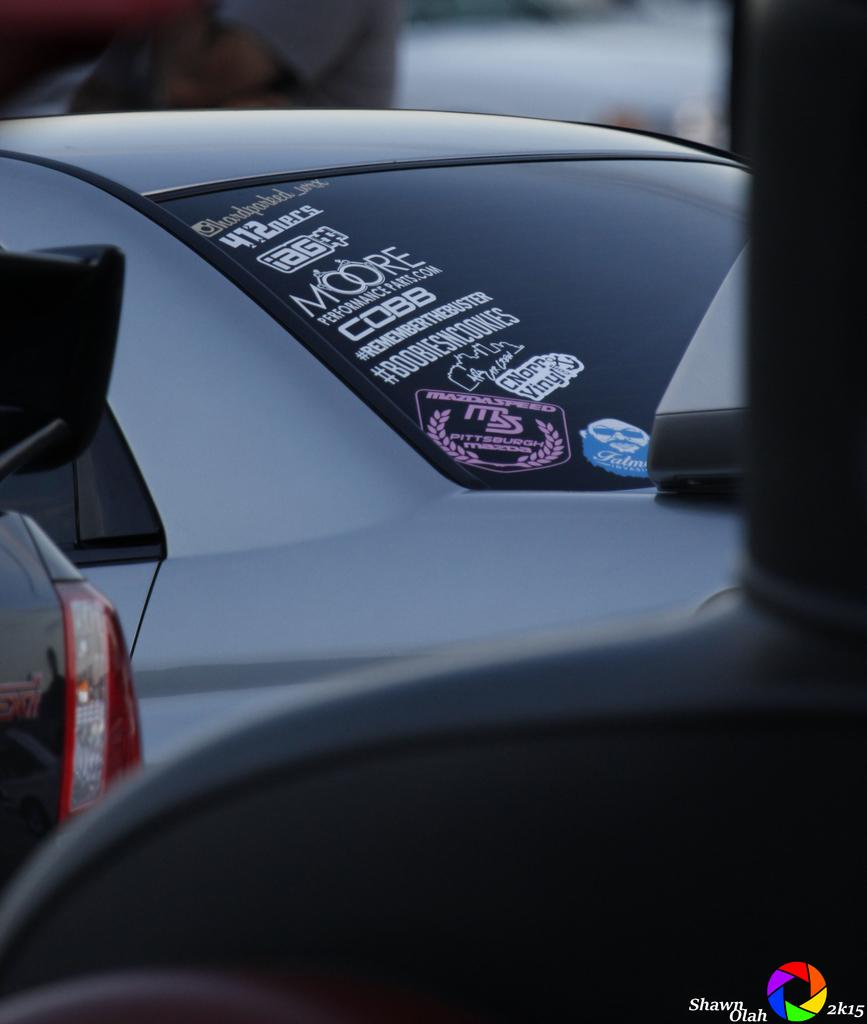What is the perspective of the image? The image is taken from a vehicle. What can be seen in the center of the image? There are cars in the center of the image. Can you describe the quality of the image? The top part of the image is blurred. What type of baseball is being played in the image? There is no baseball or any indication of a game being played in the image. 